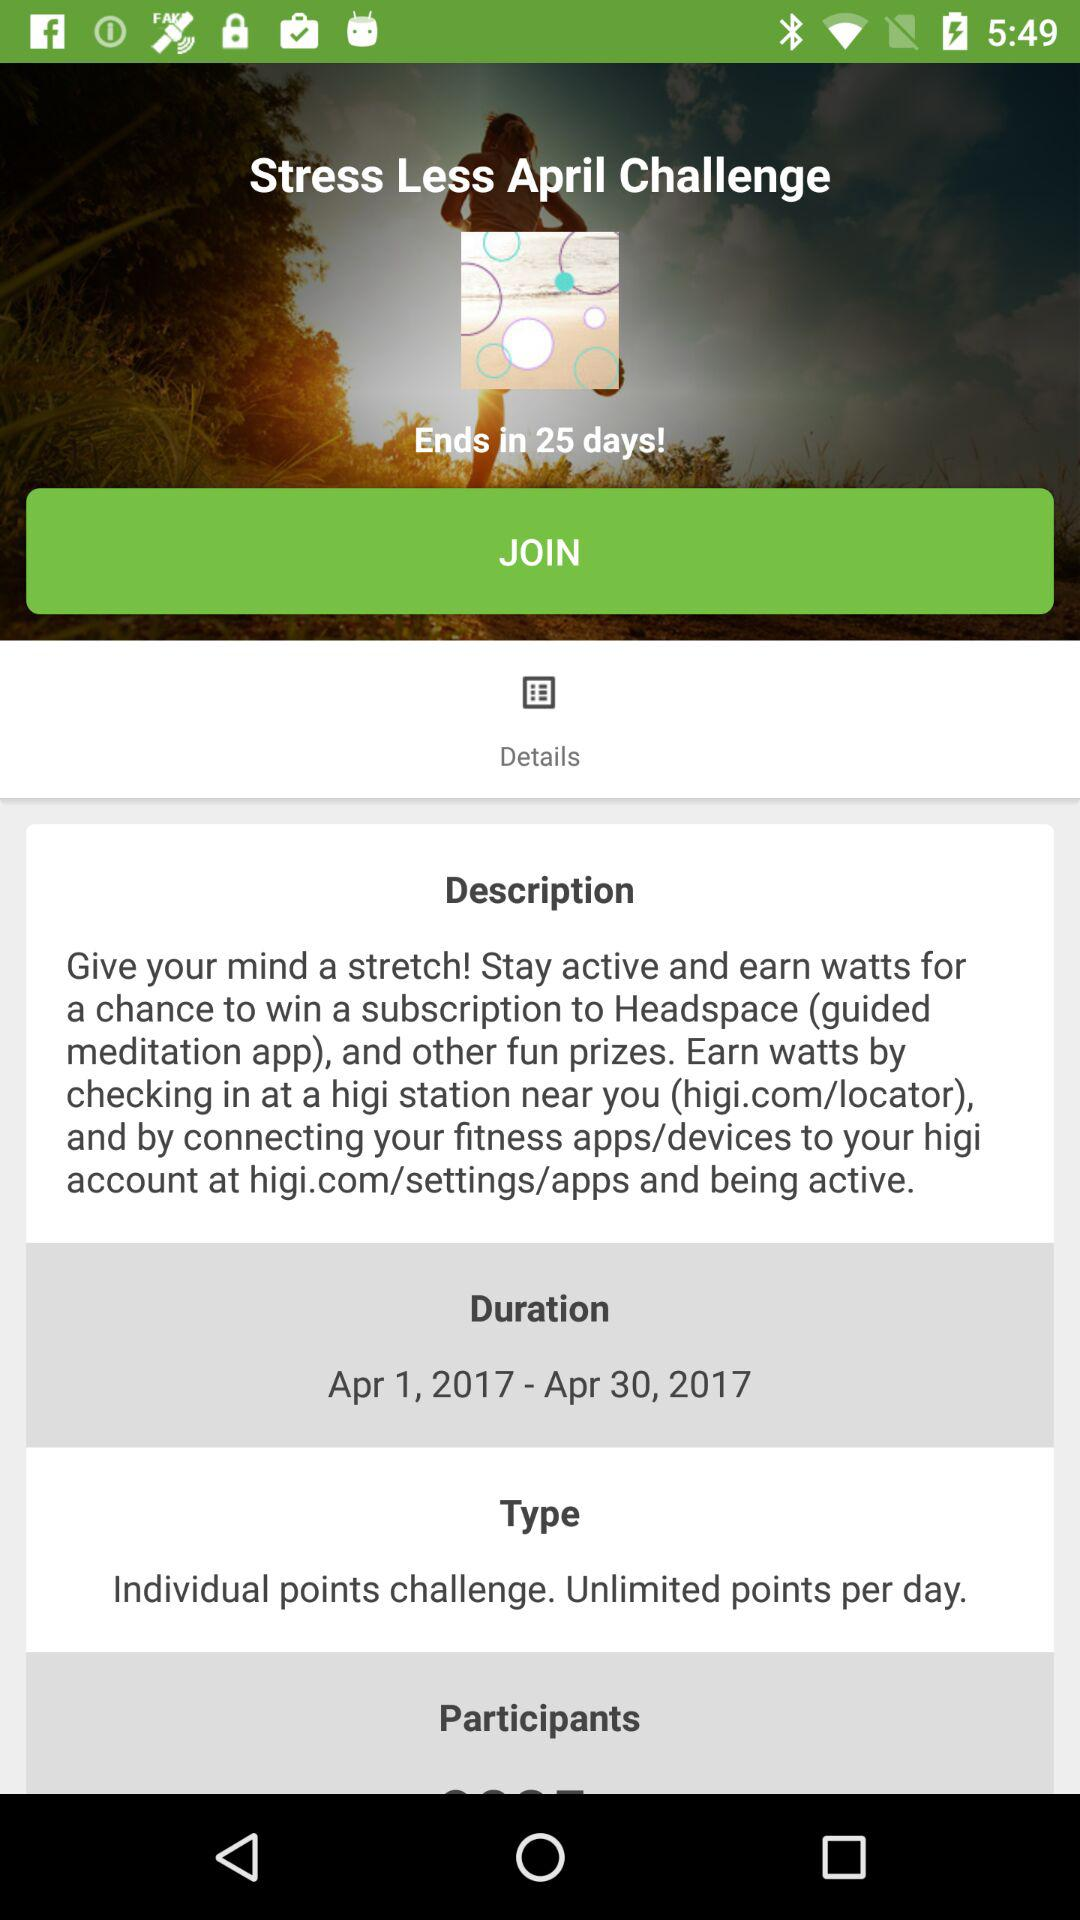What is the date range mentioned in "Duration"? The date range mentioned in "Duration" is from April 1, 2017 to April 30, 2017. 